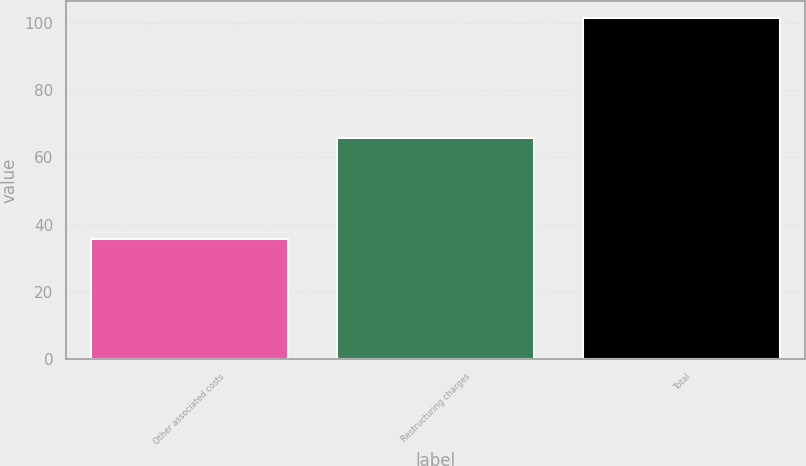Convert chart. <chart><loc_0><loc_0><loc_500><loc_500><bar_chart><fcel>Other associated costs<fcel>Restructuring charges<fcel>Total<nl><fcel>35.8<fcel>65.7<fcel>101.5<nl></chart> 